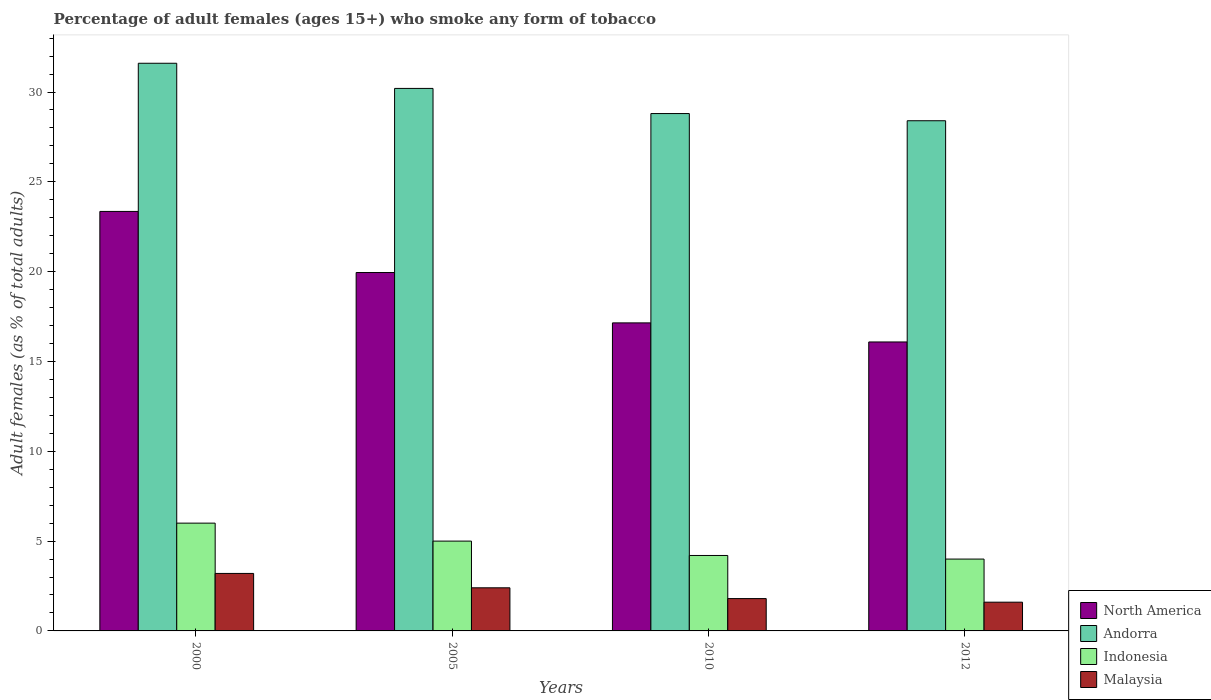How many different coloured bars are there?
Ensure brevity in your answer.  4. Are the number of bars on each tick of the X-axis equal?
Your answer should be very brief. Yes. How many bars are there on the 3rd tick from the left?
Your response must be concise. 4. How many bars are there on the 3rd tick from the right?
Ensure brevity in your answer.  4. What is the label of the 4th group of bars from the left?
Offer a terse response. 2012. What is the percentage of adult females who smoke in Andorra in 2000?
Provide a succinct answer. 31.6. Across all years, what is the maximum percentage of adult females who smoke in Indonesia?
Provide a short and direct response. 6. What is the total percentage of adult females who smoke in Andorra in the graph?
Your response must be concise. 119. What is the difference between the percentage of adult females who smoke in Andorra in 2000 and that in 2005?
Your answer should be very brief. 1.4. What is the difference between the percentage of adult females who smoke in Andorra in 2010 and the percentage of adult females who smoke in Malaysia in 2005?
Provide a succinct answer. 26.4. What is the average percentage of adult females who smoke in Malaysia per year?
Ensure brevity in your answer.  2.25. In the year 2010, what is the difference between the percentage of adult females who smoke in Malaysia and percentage of adult females who smoke in Indonesia?
Give a very brief answer. -2.4. In how many years, is the percentage of adult females who smoke in North America greater than 22 %?
Make the answer very short. 1. What is the ratio of the percentage of adult females who smoke in Andorra in 2000 to that in 2010?
Offer a terse response. 1.1. Is the percentage of adult females who smoke in Indonesia in 2000 less than that in 2012?
Keep it short and to the point. No. What is the difference between the highest and the second highest percentage of adult females who smoke in North America?
Your answer should be very brief. 3.4. What does the 1st bar from the right in 2010 represents?
Your answer should be compact. Malaysia. Is it the case that in every year, the sum of the percentage of adult females who smoke in North America and percentage of adult females who smoke in Malaysia is greater than the percentage of adult females who smoke in Andorra?
Your answer should be very brief. No. How many years are there in the graph?
Provide a short and direct response. 4. Are the values on the major ticks of Y-axis written in scientific E-notation?
Keep it short and to the point. No. What is the title of the graph?
Keep it short and to the point. Percentage of adult females (ages 15+) who smoke any form of tobacco. Does "Guyana" appear as one of the legend labels in the graph?
Provide a succinct answer. No. What is the label or title of the Y-axis?
Your answer should be compact. Adult females (as % of total adults). What is the Adult females (as % of total adults) of North America in 2000?
Your answer should be very brief. 23.35. What is the Adult females (as % of total adults) in Andorra in 2000?
Offer a very short reply. 31.6. What is the Adult females (as % of total adults) of North America in 2005?
Provide a succinct answer. 19.95. What is the Adult females (as % of total adults) of Andorra in 2005?
Give a very brief answer. 30.2. What is the Adult females (as % of total adults) in Malaysia in 2005?
Your answer should be compact. 2.4. What is the Adult females (as % of total adults) of North America in 2010?
Offer a terse response. 17.15. What is the Adult females (as % of total adults) of Andorra in 2010?
Your response must be concise. 28.8. What is the Adult females (as % of total adults) in North America in 2012?
Your answer should be very brief. 16.09. What is the Adult females (as % of total adults) of Andorra in 2012?
Make the answer very short. 28.4. What is the Adult females (as % of total adults) of Indonesia in 2012?
Offer a very short reply. 4. What is the Adult females (as % of total adults) of Malaysia in 2012?
Keep it short and to the point. 1.6. Across all years, what is the maximum Adult females (as % of total adults) in North America?
Your answer should be very brief. 23.35. Across all years, what is the maximum Adult females (as % of total adults) in Andorra?
Keep it short and to the point. 31.6. Across all years, what is the maximum Adult females (as % of total adults) in Malaysia?
Provide a succinct answer. 3.2. Across all years, what is the minimum Adult females (as % of total adults) in North America?
Offer a terse response. 16.09. Across all years, what is the minimum Adult females (as % of total adults) in Andorra?
Your answer should be very brief. 28.4. What is the total Adult females (as % of total adults) in North America in the graph?
Offer a terse response. 76.54. What is the total Adult females (as % of total adults) in Andorra in the graph?
Make the answer very short. 119. What is the total Adult females (as % of total adults) in Malaysia in the graph?
Provide a succinct answer. 9. What is the difference between the Adult females (as % of total adults) of North America in 2000 and that in 2005?
Provide a succinct answer. 3.4. What is the difference between the Adult females (as % of total adults) of Indonesia in 2000 and that in 2005?
Offer a terse response. 1. What is the difference between the Adult females (as % of total adults) of North America in 2000 and that in 2010?
Offer a very short reply. 6.2. What is the difference between the Adult females (as % of total adults) in North America in 2000 and that in 2012?
Your response must be concise. 7.27. What is the difference between the Adult females (as % of total adults) of Andorra in 2000 and that in 2012?
Offer a very short reply. 3.2. What is the difference between the Adult females (as % of total adults) of Indonesia in 2000 and that in 2012?
Offer a very short reply. 2. What is the difference between the Adult females (as % of total adults) in Malaysia in 2000 and that in 2012?
Give a very brief answer. 1.6. What is the difference between the Adult females (as % of total adults) of North America in 2005 and that in 2010?
Give a very brief answer. 2.8. What is the difference between the Adult females (as % of total adults) in Andorra in 2005 and that in 2010?
Provide a succinct answer. 1.4. What is the difference between the Adult females (as % of total adults) of Indonesia in 2005 and that in 2010?
Provide a succinct answer. 0.8. What is the difference between the Adult females (as % of total adults) of North America in 2005 and that in 2012?
Your answer should be very brief. 3.86. What is the difference between the Adult females (as % of total adults) of Indonesia in 2005 and that in 2012?
Offer a terse response. 1. What is the difference between the Adult females (as % of total adults) in Malaysia in 2005 and that in 2012?
Provide a short and direct response. 0.8. What is the difference between the Adult females (as % of total adults) of North America in 2010 and that in 2012?
Provide a short and direct response. 1.06. What is the difference between the Adult females (as % of total adults) in Andorra in 2010 and that in 2012?
Ensure brevity in your answer.  0.4. What is the difference between the Adult females (as % of total adults) of Malaysia in 2010 and that in 2012?
Give a very brief answer. 0.2. What is the difference between the Adult females (as % of total adults) in North America in 2000 and the Adult females (as % of total adults) in Andorra in 2005?
Your response must be concise. -6.85. What is the difference between the Adult females (as % of total adults) of North America in 2000 and the Adult females (as % of total adults) of Indonesia in 2005?
Your response must be concise. 18.35. What is the difference between the Adult females (as % of total adults) of North America in 2000 and the Adult females (as % of total adults) of Malaysia in 2005?
Provide a short and direct response. 20.95. What is the difference between the Adult females (as % of total adults) of Andorra in 2000 and the Adult females (as % of total adults) of Indonesia in 2005?
Your response must be concise. 26.6. What is the difference between the Adult females (as % of total adults) of Andorra in 2000 and the Adult females (as % of total adults) of Malaysia in 2005?
Offer a terse response. 29.2. What is the difference between the Adult females (as % of total adults) in North America in 2000 and the Adult females (as % of total adults) in Andorra in 2010?
Provide a succinct answer. -5.45. What is the difference between the Adult females (as % of total adults) in North America in 2000 and the Adult females (as % of total adults) in Indonesia in 2010?
Provide a short and direct response. 19.15. What is the difference between the Adult females (as % of total adults) in North America in 2000 and the Adult females (as % of total adults) in Malaysia in 2010?
Provide a succinct answer. 21.55. What is the difference between the Adult females (as % of total adults) of Andorra in 2000 and the Adult females (as % of total adults) of Indonesia in 2010?
Offer a very short reply. 27.4. What is the difference between the Adult females (as % of total adults) in Andorra in 2000 and the Adult females (as % of total adults) in Malaysia in 2010?
Offer a very short reply. 29.8. What is the difference between the Adult females (as % of total adults) of North America in 2000 and the Adult females (as % of total adults) of Andorra in 2012?
Your answer should be compact. -5.05. What is the difference between the Adult females (as % of total adults) of North America in 2000 and the Adult females (as % of total adults) of Indonesia in 2012?
Give a very brief answer. 19.35. What is the difference between the Adult females (as % of total adults) of North America in 2000 and the Adult females (as % of total adults) of Malaysia in 2012?
Your answer should be very brief. 21.75. What is the difference between the Adult females (as % of total adults) in Andorra in 2000 and the Adult females (as % of total adults) in Indonesia in 2012?
Offer a terse response. 27.6. What is the difference between the Adult females (as % of total adults) of Andorra in 2000 and the Adult females (as % of total adults) of Malaysia in 2012?
Give a very brief answer. 30. What is the difference between the Adult females (as % of total adults) in Indonesia in 2000 and the Adult females (as % of total adults) in Malaysia in 2012?
Keep it short and to the point. 4.4. What is the difference between the Adult females (as % of total adults) of North America in 2005 and the Adult females (as % of total adults) of Andorra in 2010?
Your answer should be very brief. -8.85. What is the difference between the Adult females (as % of total adults) in North America in 2005 and the Adult females (as % of total adults) in Indonesia in 2010?
Your answer should be compact. 15.75. What is the difference between the Adult females (as % of total adults) of North America in 2005 and the Adult females (as % of total adults) of Malaysia in 2010?
Offer a terse response. 18.15. What is the difference between the Adult females (as % of total adults) of Andorra in 2005 and the Adult females (as % of total adults) of Indonesia in 2010?
Your answer should be very brief. 26. What is the difference between the Adult females (as % of total adults) in Andorra in 2005 and the Adult females (as % of total adults) in Malaysia in 2010?
Your answer should be compact. 28.4. What is the difference between the Adult females (as % of total adults) in North America in 2005 and the Adult females (as % of total adults) in Andorra in 2012?
Make the answer very short. -8.45. What is the difference between the Adult females (as % of total adults) in North America in 2005 and the Adult females (as % of total adults) in Indonesia in 2012?
Your response must be concise. 15.95. What is the difference between the Adult females (as % of total adults) of North America in 2005 and the Adult females (as % of total adults) of Malaysia in 2012?
Make the answer very short. 18.35. What is the difference between the Adult females (as % of total adults) in Andorra in 2005 and the Adult females (as % of total adults) in Indonesia in 2012?
Keep it short and to the point. 26.2. What is the difference between the Adult females (as % of total adults) of Andorra in 2005 and the Adult females (as % of total adults) of Malaysia in 2012?
Offer a terse response. 28.6. What is the difference between the Adult females (as % of total adults) in Indonesia in 2005 and the Adult females (as % of total adults) in Malaysia in 2012?
Make the answer very short. 3.4. What is the difference between the Adult females (as % of total adults) of North America in 2010 and the Adult females (as % of total adults) of Andorra in 2012?
Your answer should be compact. -11.25. What is the difference between the Adult females (as % of total adults) in North America in 2010 and the Adult females (as % of total adults) in Indonesia in 2012?
Keep it short and to the point. 13.15. What is the difference between the Adult females (as % of total adults) in North America in 2010 and the Adult females (as % of total adults) in Malaysia in 2012?
Your response must be concise. 15.55. What is the difference between the Adult females (as % of total adults) of Andorra in 2010 and the Adult females (as % of total adults) of Indonesia in 2012?
Provide a short and direct response. 24.8. What is the difference between the Adult females (as % of total adults) in Andorra in 2010 and the Adult females (as % of total adults) in Malaysia in 2012?
Your answer should be compact. 27.2. What is the average Adult females (as % of total adults) in North America per year?
Your answer should be compact. 19.13. What is the average Adult females (as % of total adults) of Andorra per year?
Ensure brevity in your answer.  29.75. What is the average Adult females (as % of total adults) in Malaysia per year?
Your answer should be compact. 2.25. In the year 2000, what is the difference between the Adult females (as % of total adults) of North America and Adult females (as % of total adults) of Andorra?
Offer a very short reply. -8.25. In the year 2000, what is the difference between the Adult females (as % of total adults) of North America and Adult females (as % of total adults) of Indonesia?
Offer a very short reply. 17.35. In the year 2000, what is the difference between the Adult females (as % of total adults) of North America and Adult females (as % of total adults) of Malaysia?
Offer a terse response. 20.15. In the year 2000, what is the difference between the Adult females (as % of total adults) in Andorra and Adult females (as % of total adults) in Indonesia?
Offer a terse response. 25.6. In the year 2000, what is the difference between the Adult females (as % of total adults) of Andorra and Adult females (as % of total adults) of Malaysia?
Offer a very short reply. 28.4. In the year 2005, what is the difference between the Adult females (as % of total adults) of North America and Adult females (as % of total adults) of Andorra?
Ensure brevity in your answer.  -10.25. In the year 2005, what is the difference between the Adult females (as % of total adults) in North America and Adult females (as % of total adults) in Indonesia?
Offer a terse response. 14.95. In the year 2005, what is the difference between the Adult females (as % of total adults) of North America and Adult females (as % of total adults) of Malaysia?
Keep it short and to the point. 17.55. In the year 2005, what is the difference between the Adult females (as % of total adults) of Andorra and Adult females (as % of total adults) of Indonesia?
Offer a very short reply. 25.2. In the year 2005, what is the difference between the Adult females (as % of total adults) in Andorra and Adult females (as % of total adults) in Malaysia?
Your response must be concise. 27.8. In the year 2010, what is the difference between the Adult females (as % of total adults) in North America and Adult females (as % of total adults) in Andorra?
Give a very brief answer. -11.65. In the year 2010, what is the difference between the Adult females (as % of total adults) of North America and Adult females (as % of total adults) of Indonesia?
Your response must be concise. 12.95. In the year 2010, what is the difference between the Adult females (as % of total adults) of North America and Adult females (as % of total adults) of Malaysia?
Your answer should be very brief. 15.35. In the year 2010, what is the difference between the Adult females (as % of total adults) in Andorra and Adult females (as % of total adults) in Indonesia?
Your answer should be compact. 24.6. In the year 2012, what is the difference between the Adult females (as % of total adults) in North America and Adult females (as % of total adults) in Andorra?
Ensure brevity in your answer.  -12.31. In the year 2012, what is the difference between the Adult females (as % of total adults) of North America and Adult females (as % of total adults) of Indonesia?
Offer a terse response. 12.09. In the year 2012, what is the difference between the Adult females (as % of total adults) of North America and Adult females (as % of total adults) of Malaysia?
Provide a short and direct response. 14.49. In the year 2012, what is the difference between the Adult females (as % of total adults) in Andorra and Adult females (as % of total adults) in Indonesia?
Offer a very short reply. 24.4. In the year 2012, what is the difference between the Adult females (as % of total adults) of Andorra and Adult females (as % of total adults) of Malaysia?
Ensure brevity in your answer.  26.8. In the year 2012, what is the difference between the Adult females (as % of total adults) of Indonesia and Adult females (as % of total adults) of Malaysia?
Your answer should be very brief. 2.4. What is the ratio of the Adult females (as % of total adults) of North America in 2000 to that in 2005?
Make the answer very short. 1.17. What is the ratio of the Adult females (as % of total adults) of Andorra in 2000 to that in 2005?
Make the answer very short. 1.05. What is the ratio of the Adult females (as % of total adults) in Indonesia in 2000 to that in 2005?
Your answer should be very brief. 1.2. What is the ratio of the Adult females (as % of total adults) of Malaysia in 2000 to that in 2005?
Your response must be concise. 1.33. What is the ratio of the Adult females (as % of total adults) of North America in 2000 to that in 2010?
Ensure brevity in your answer.  1.36. What is the ratio of the Adult females (as % of total adults) of Andorra in 2000 to that in 2010?
Ensure brevity in your answer.  1.1. What is the ratio of the Adult females (as % of total adults) in Indonesia in 2000 to that in 2010?
Provide a short and direct response. 1.43. What is the ratio of the Adult females (as % of total adults) of Malaysia in 2000 to that in 2010?
Offer a terse response. 1.78. What is the ratio of the Adult females (as % of total adults) of North America in 2000 to that in 2012?
Your answer should be very brief. 1.45. What is the ratio of the Adult females (as % of total adults) in Andorra in 2000 to that in 2012?
Your answer should be very brief. 1.11. What is the ratio of the Adult females (as % of total adults) in North America in 2005 to that in 2010?
Provide a short and direct response. 1.16. What is the ratio of the Adult females (as % of total adults) in Andorra in 2005 to that in 2010?
Offer a very short reply. 1.05. What is the ratio of the Adult females (as % of total adults) in Indonesia in 2005 to that in 2010?
Ensure brevity in your answer.  1.19. What is the ratio of the Adult females (as % of total adults) of Malaysia in 2005 to that in 2010?
Your answer should be very brief. 1.33. What is the ratio of the Adult females (as % of total adults) in North America in 2005 to that in 2012?
Your response must be concise. 1.24. What is the ratio of the Adult females (as % of total adults) of Andorra in 2005 to that in 2012?
Offer a terse response. 1.06. What is the ratio of the Adult females (as % of total adults) of North America in 2010 to that in 2012?
Offer a terse response. 1.07. What is the ratio of the Adult females (as % of total adults) in Andorra in 2010 to that in 2012?
Your answer should be very brief. 1.01. What is the ratio of the Adult females (as % of total adults) of Indonesia in 2010 to that in 2012?
Your answer should be compact. 1.05. What is the difference between the highest and the second highest Adult females (as % of total adults) in North America?
Offer a very short reply. 3.4. What is the difference between the highest and the second highest Adult females (as % of total adults) of Andorra?
Provide a short and direct response. 1.4. What is the difference between the highest and the second highest Adult females (as % of total adults) of Indonesia?
Your response must be concise. 1. What is the difference between the highest and the second highest Adult females (as % of total adults) in Malaysia?
Your answer should be very brief. 0.8. What is the difference between the highest and the lowest Adult females (as % of total adults) of North America?
Make the answer very short. 7.27. What is the difference between the highest and the lowest Adult females (as % of total adults) of Andorra?
Offer a terse response. 3.2. What is the difference between the highest and the lowest Adult females (as % of total adults) in Indonesia?
Offer a terse response. 2. What is the difference between the highest and the lowest Adult females (as % of total adults) of Malaysia?
Offer a terse response. 1.6. 